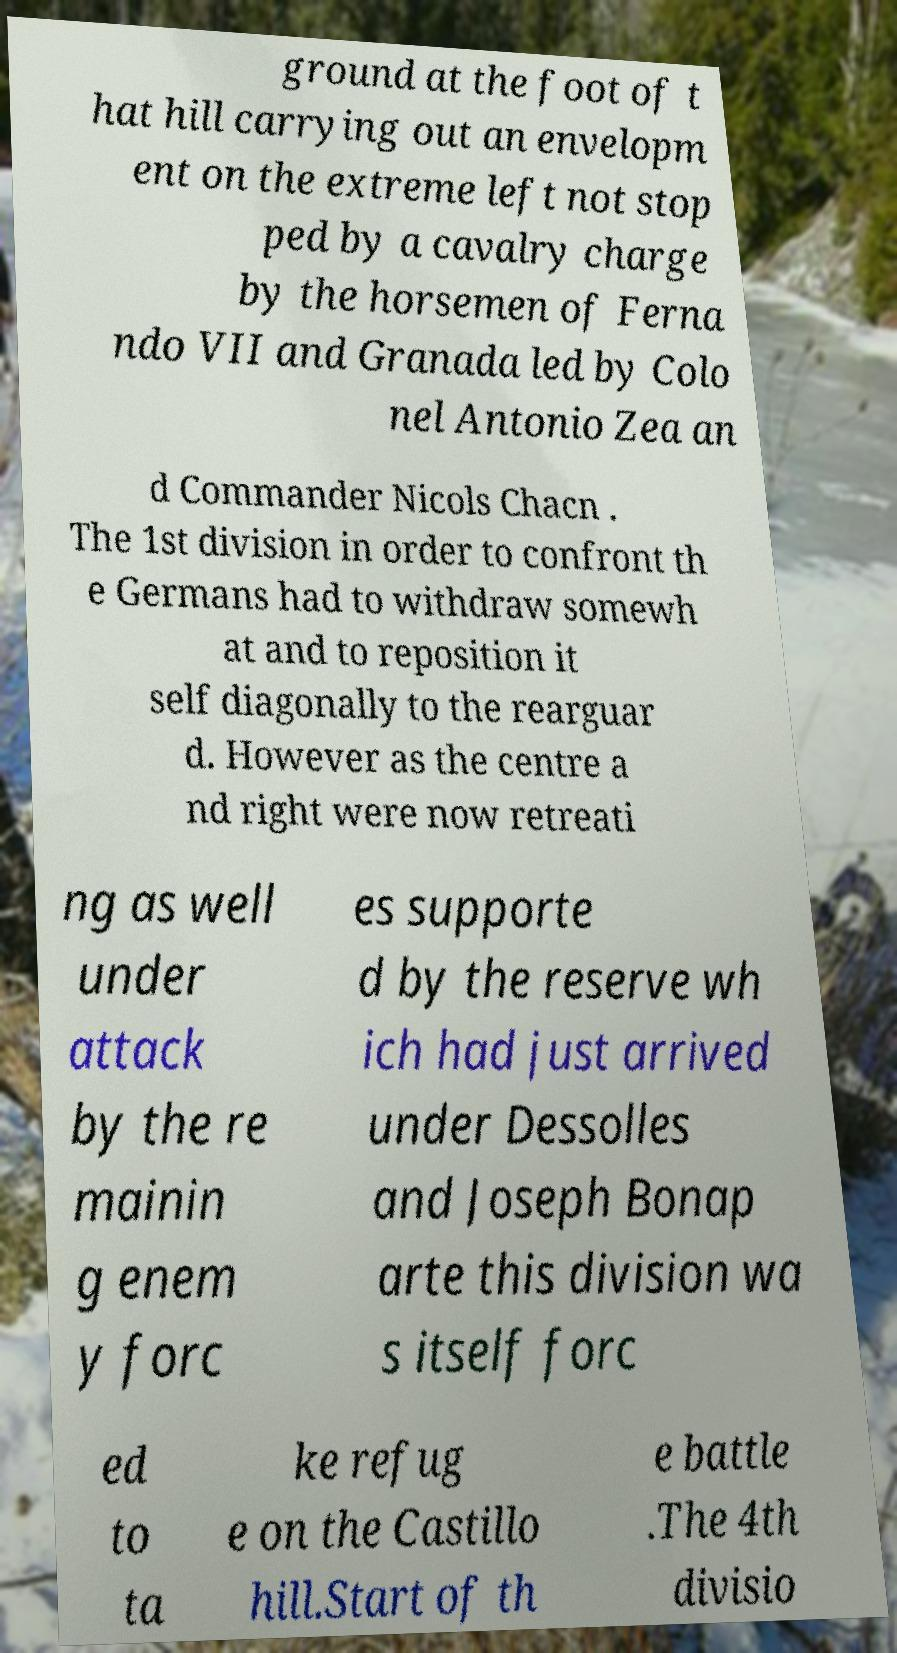Please read and relay the text visible in this image. What does it say? ground at the foot of t hat hill carrying out an envelopm ent on the extreme left not stop ped by a cavalry charge by the horsemen of Ferna ndo VII and Granada led by Colo nel Antonio Zea an d Commander Nicols Chacn . The 1st division in order to confront th e Germans had to withdraw somewh at and to reposition it self diagonally to the rearguar d. However as the centre a nd right were now retreati ng as well under attack by the re mainin g enem y forc es supporte d by the reserve wh ich had just arrived under Dessolles and Joseph Bonap arte this division wa s itself forc ed to ta ke refug e on the Castillo hill.Start of th e battle .The 4th divisio 